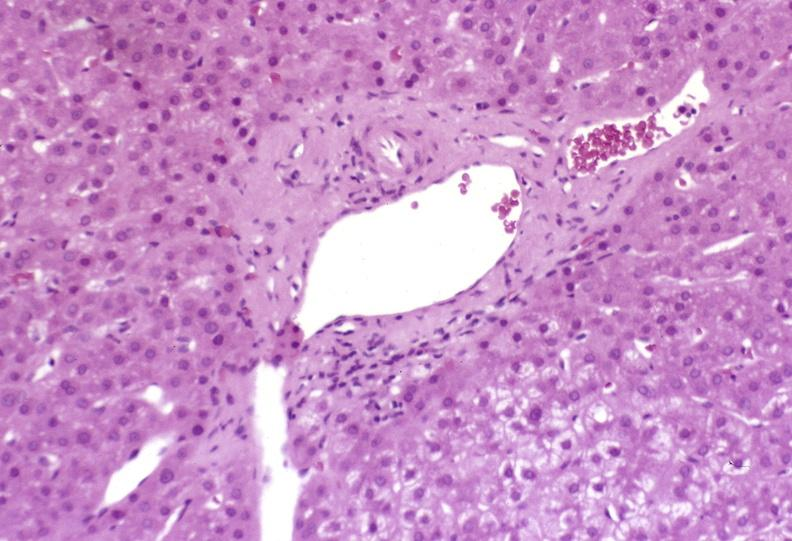does this image show mild-to-moderate acute rejection?
Answer the question using a single word or phrase. Yes 